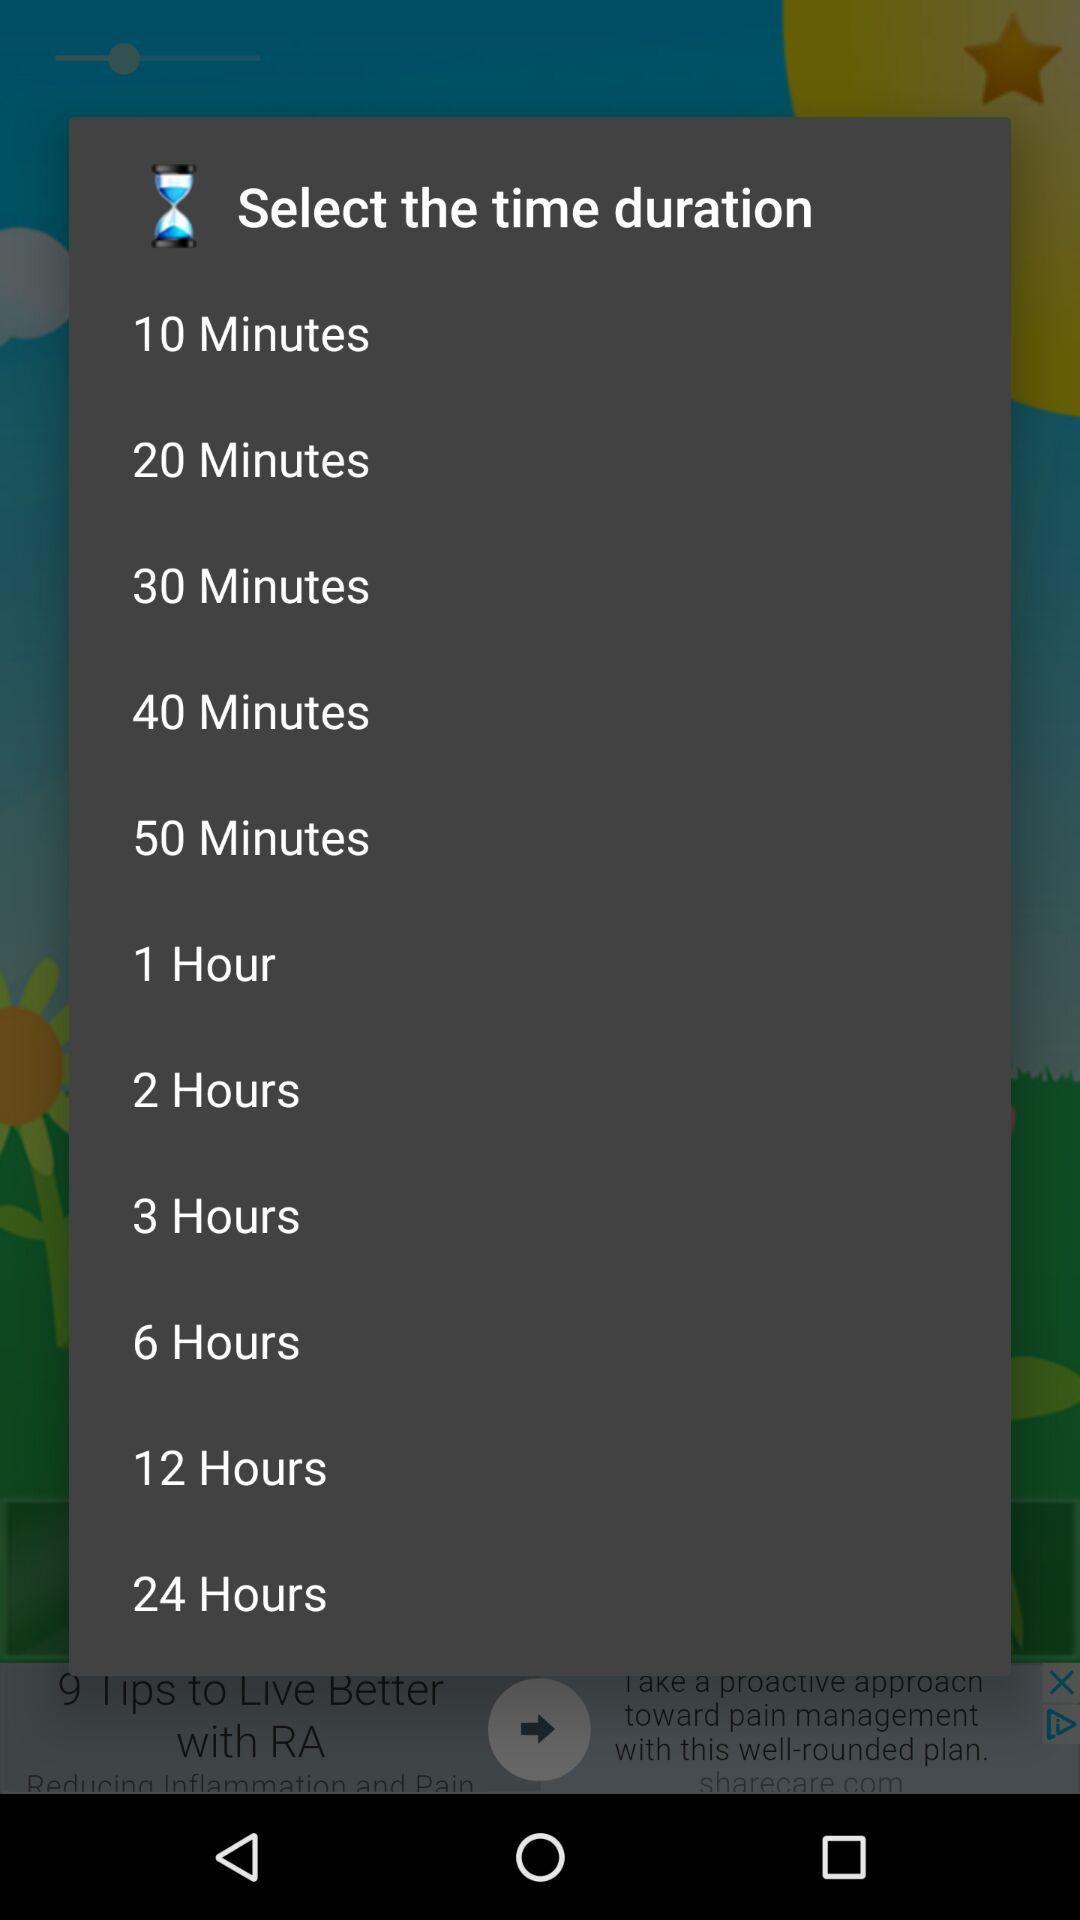How many minutes are there between the 10 minute and 30 minute options?
Answer the question using a single word or phrase. 20 